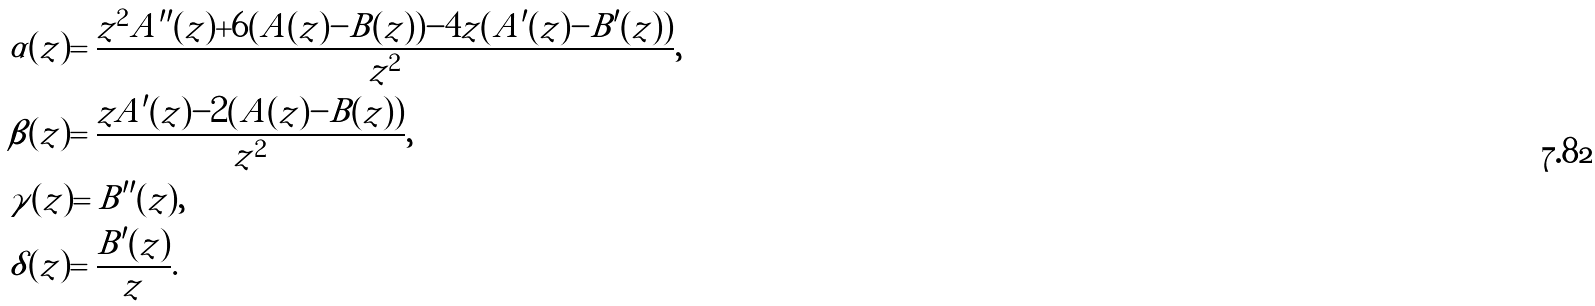Convert formula to latex. <formula><loc_0><loc_0><loc_500><loc_500>& \alpha ( z ) = \frac { z ^ { 2 } A ^ { \prime \prime } ( z ) + 6 ( A ( z ) - B ( z ) ) - 4 z ( A ^ { \prime } ( z ) - B ^ { \prime } ( z ) ) } { z ^ { 2 } } , \\ & \beta ( z ) = \frac { z A ^ { \prime } ( z ) - 2 ( A ( z ) - B ( z ) ) } { z ^ { 2 } } , \\ & \gamma ( z ) = B ^ { \prime \prime } ( z ) , \\ & \delta ( z ) = \frac { B ^ { \prime } ( z ) } { z } .</formula> 